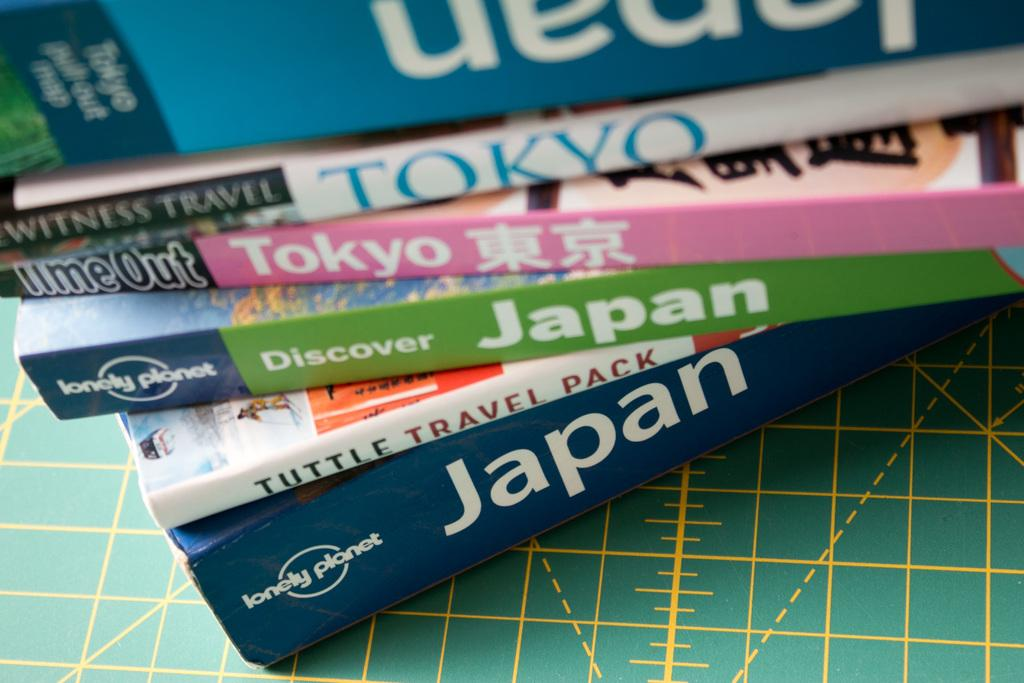<image>
Summarize the visual content of the image. A collection of books includes the title Discover Japan. 